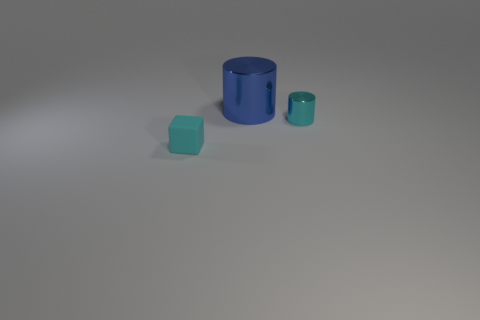Add 2 small red blocks. How many objects exist? 5 Subtract all cylinders. How many objects are left? 1 Add 1 small metallic cylinders. How many small metallic cylinders are left? 2 Add 3 small blue cylinders. How many small blue cylinders exist? 3 Subtract 0 brown cylinders. How many objects are left? 3 Subtract all big cylinders. Subtract all gray cubes. How many objects are left? 2 